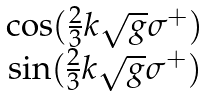<formula> <loc_0><loc_0><loc_500><loc_500>\begin{matrix} \cos ( \frac { 2 } { 3 } k \sqrt { g } \sigma ^ { + } ) \\ \sin ( \frac { 2 } { 3 } k \sqrt { g } \sigma ^ { + } ) \end{matrix}</formula> 